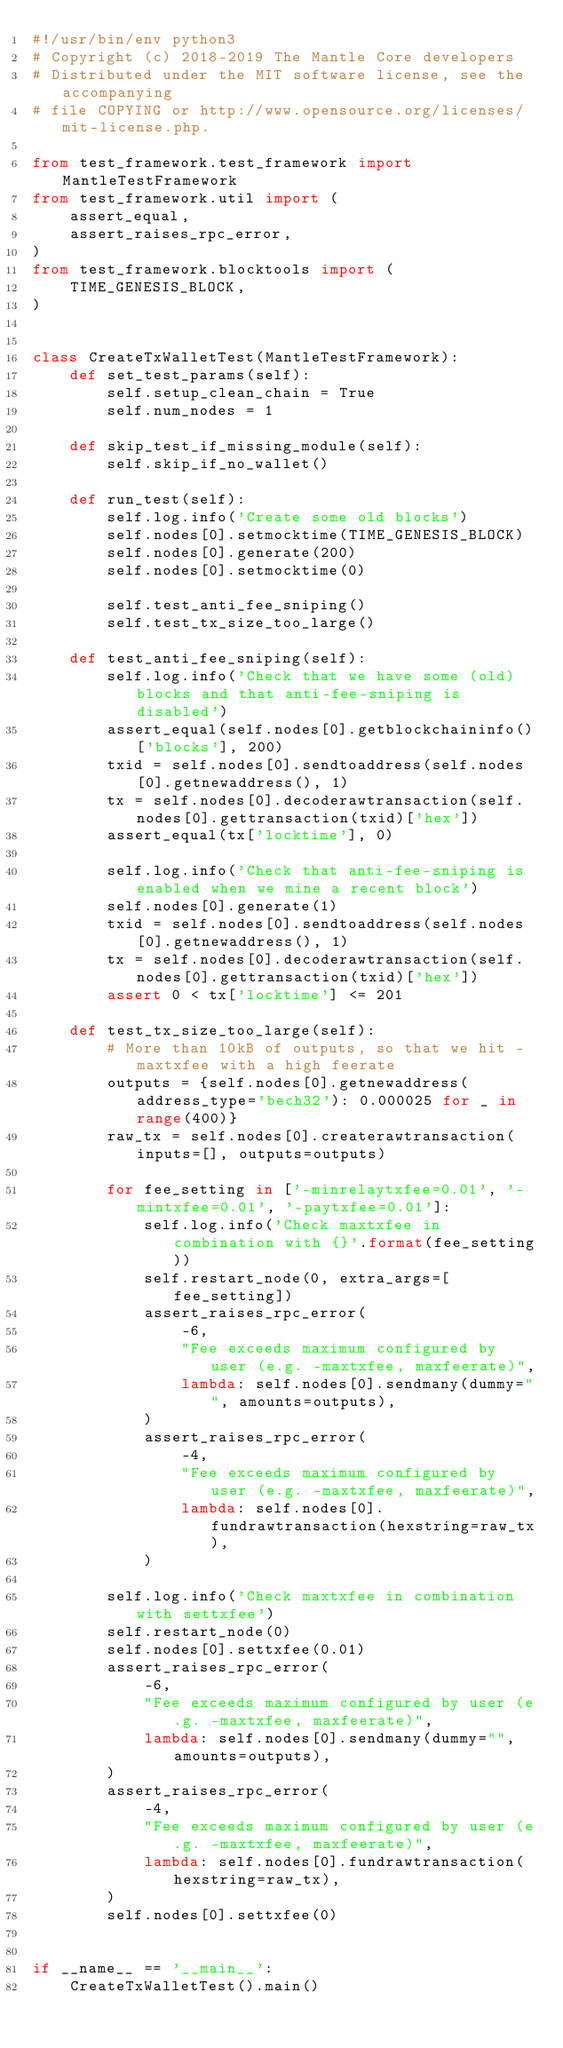Convert code to text. <code><loc_0><loc_0><loc_500><loc_500><_Python_>#!/usr/bin/env python3
# Copyright (c) 2018-2019 The Mantle Core developers
# Distributed under the MIT software license, see the accompanying
# file COPYING or http://www.opensource.org/licenses/mit-license.php.

from test_framework.test_framework import MantleTestFramework
from test_framework.util import (
    assert_equal,
    assert_raises_rpc_error,
)
from test_framework.blocktools import (
    TIME_GENESIS_BLOCK,
)


class CreateTxWalletTest(MantleTestFramework):
    def set_test_params(self):
        self.setup_clean_chain = True
        self.num_nodes = 1

    def skip_test_if_missing_module(self):
        self.skip_if_no_wallet()

    def run_test(self):
        self.log.info('Create some old blocks')
        self.nodes[0].setmocktime(TIME_GENESIS_BLOCK)
        self.nodes[0].generate(200)
        self.nodes[0].setmocktime(0)

        self.test_anti_fee_sniping()
        self.test_tx_size_too_large()

    def test_anti_fee_sniping(self):
        self.log.info('Check that we have some (old) blocks and that anti-fee-sniping is disabled')
        assert_equal(self.nodes[0].getblockchaininfo()['blocks'], 200)
        txid = self.nodes[0].sendtoaddress(self.nodes[0].getnewaddress(), 1)
        tx = self.nodes[0].decoderawtransaction(self.nodes[0].gettransaction(txid)['hex'])
        assert_equal(tx['locktime'], 0)

        self.log.info('Check that anti-fee-sniping is enabled when we mine a recent block')
        self.nodes[0].generate(1)
        txid = self.nodes[0].sendtoaddress(self.nodes[0].getnewaddress(), 1)
        tx = self.nodes[0].decoderawtransaction(self.nodes[0].gettransaction(txid)['hex'])
        assert 0 < tx['locktime'] <= 201

    def test_tx_size_too_large(self):
        # More than 10kB of outputs, so that we hit -maxtxfee with a high feerate
        outputs = {self.nodes[0].getnewaddress(address_type='bech32'): 0.000025 for _ in range(400)}
        raw_tx = self.nodes[0].createrawtransaction(inputs=[], outputs=outputs)

        for fee_setting in ['-minrelaytxfee=0.01', '-mintxfee=0.01', '-paytxfee=0.01']:
            self.log.info('Check maxtxfee in combination with {}'.format(fee_setting))
            self.restart_node(0, extra_args=[fee_setting])
            assert_raises_rpc_error(
                -6,
                "Fee exceeds maximum configured by user (e.g. -maxtxfee, maxfeerate)",
                lambda: self.nodes[0].sendmany(dummy="", amounts=outputs),
            )
            assert_raises_rpc_error(
                -4,
                "Fee exceeds maximum configured by user (e.g. -maxtxfee, maxfeerate)",
                lambda: self.nodes[0].fundrawtransaction(hexstring=raw_tx),
            )

        self.log.info('Check maxtxfee in combination with settxfee')
        self.restart_node(0)
        self.nodes[0].settxfee(0.01)
        assert_raises_rpc_error(
            -6,
            "Fee exceeds maximum configured by user (e.g. -maxtxfee, maxfeerate)",
            lambda: self.nodes[0].sendmany(dummy="", amounts=outputs),
        )
        assert_raises_rpc_error(
            -4,
            "Fee exceeds maximum configured by user (e.g. -maxtxfee, maxfeerate)",
            lambda: self.nodes[0].fundrawtransaction(hexstring=raw_tx),
        )
        self.nodes[0].settxfee(0)


if __name__ == '__main__':
    CreateTxWalletTest().main()
</code> 